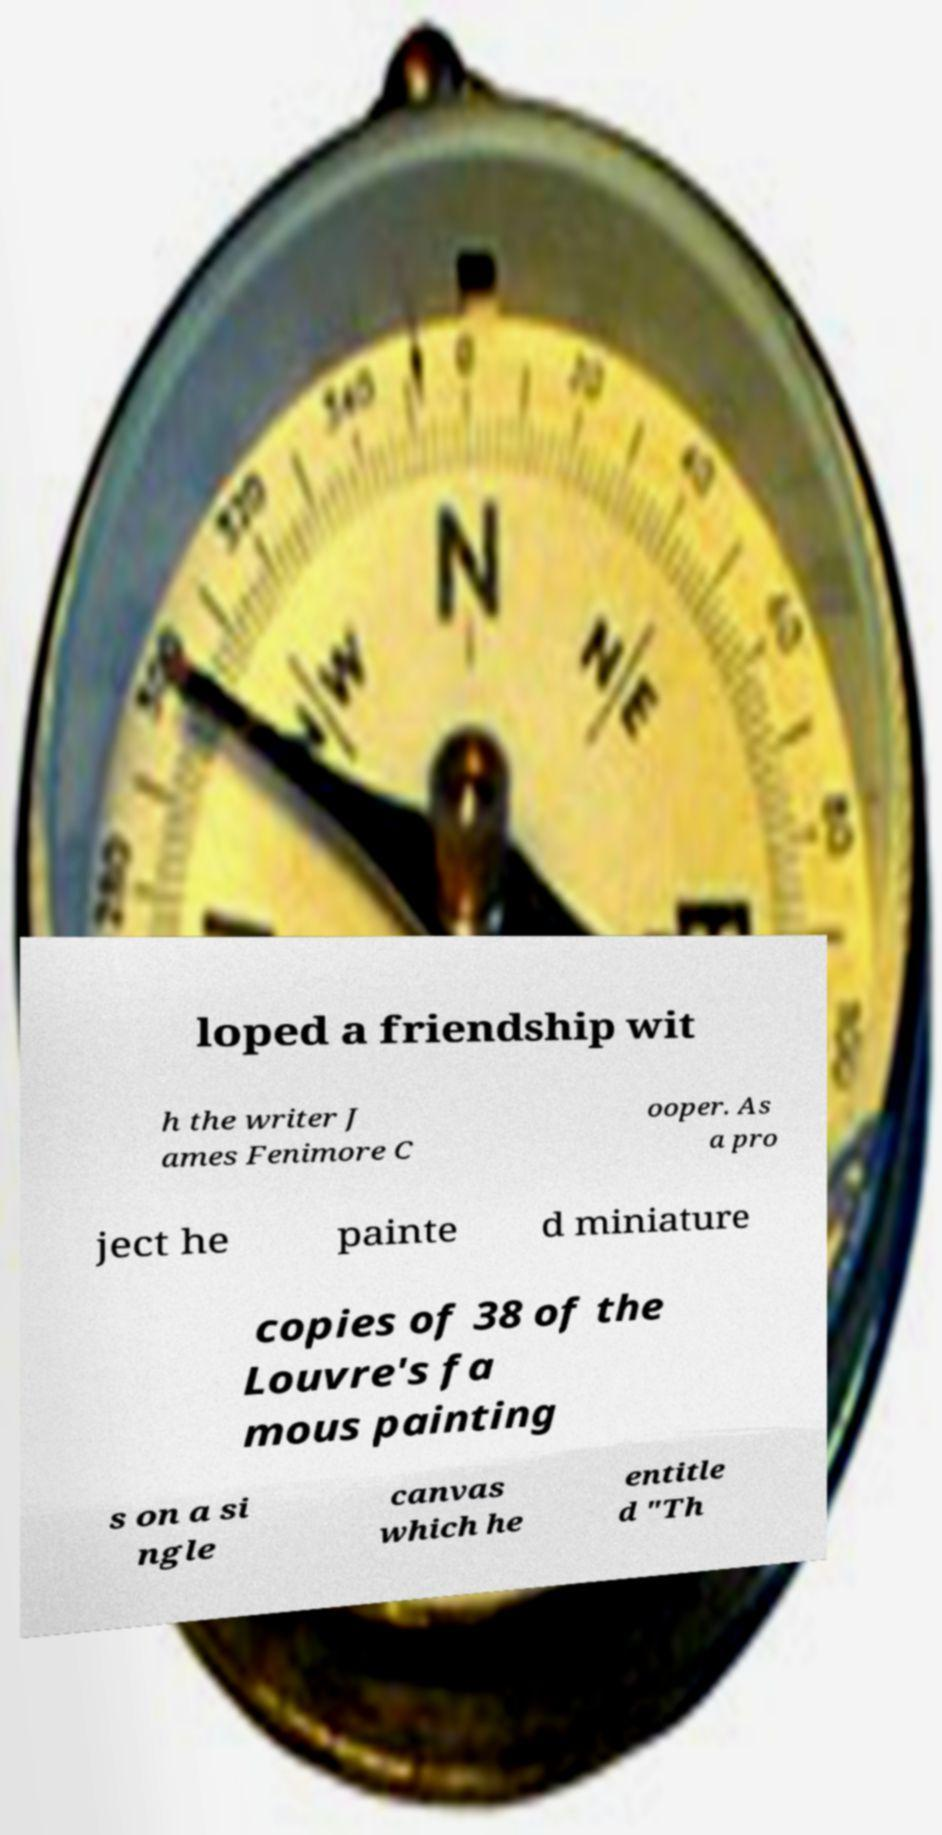Can you accurately transcribe the text from the provided image for me? loped a friendship wit h the writer J ames Fenimore C ooper. As a pro ject he painte d miniature copies of 38 of the Louvre's fa mous painting s on a si ngle canvas which he entitle d "Th 